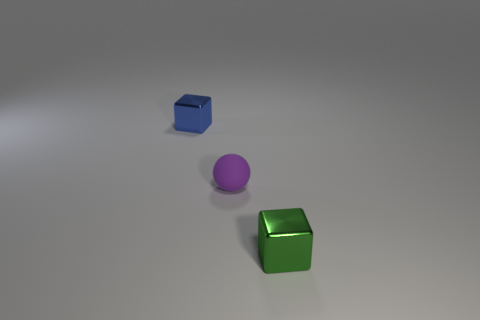There is a green object that is the same shape as the blue object; what size is it?
Ensure brevity in your answer.  Small. How many small blue blocks are behind the green metal cube?
Your response must be concise. 1. What number of gray things are small balls or big shiny spheres?
Your response must be concise. 0. The block that is behind the shiny block that is on the right side of the blue metal cube is what color?
Your response must be concise. Blue. There is a tiny thing that is in front of the sphere; what is its color?
Make the answer very short. Green. Do the shiny cube that is to the left of the green shiny object and the purple matte object have the same size?
Your answer should be compact. Yes. Are there any shiny blocks that have the same size as the rubber thing?
Offer a very short reply. Yes. What number of other objects are there of the same shape as the tiny rubber object?
Make the answer very short. 0. There is a metallic thing that is to the right of the blue shiny block; what is its shape?
Provide a succinct answer. Cube. Is the shape of the small blue thing the same as the metallic object that is in front of the purple rubber thing?
Offer a terse response. Yes. 